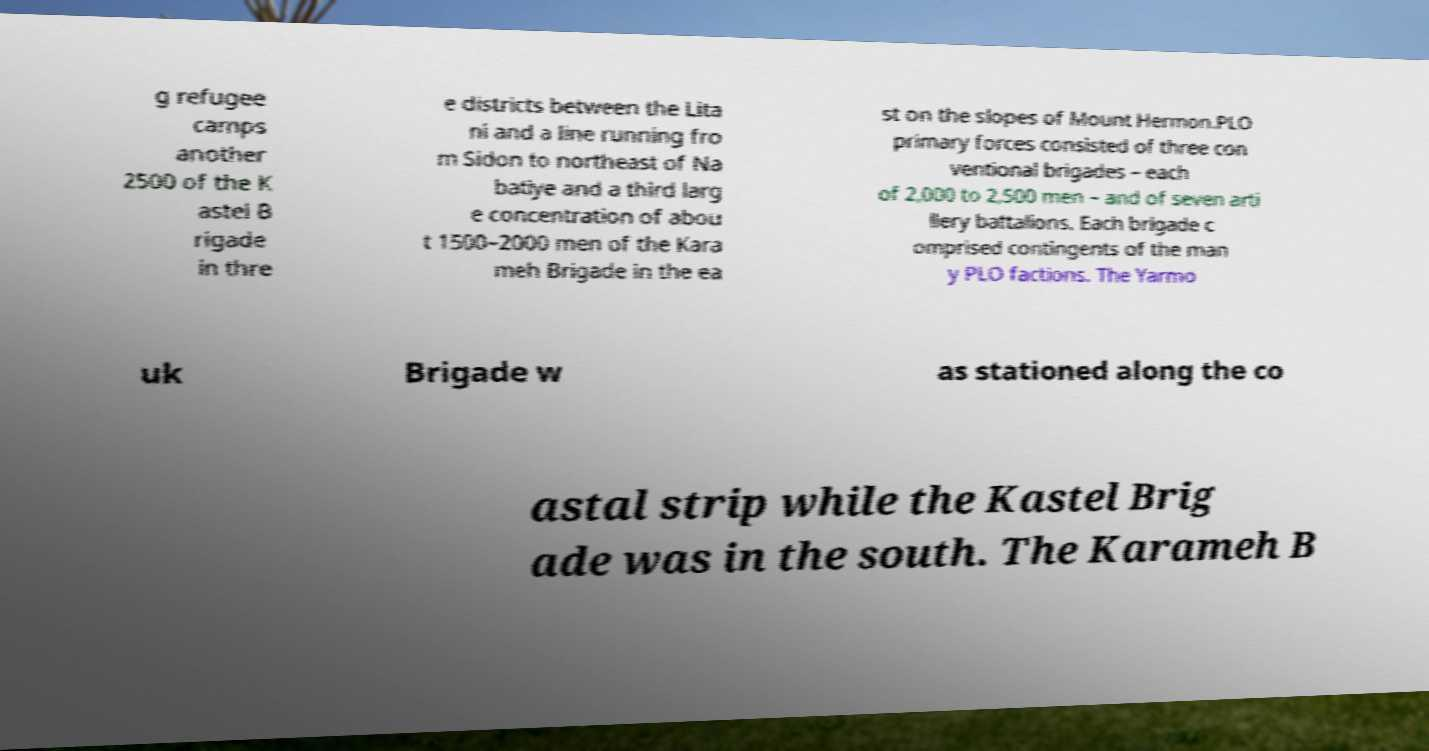For documentation purposes, I need the text within this image transcribed. Could you provide that? g refugee camps another 2500 of the K astel B rigade in thre e districts between the Lita ni and a line running fro m Sidon to northeast of Na batiye and a third larg e concentration of abou t 1500–2000 men of the Kara meh Brigade in the ea st on the slopes of Mount Hermon.PLO primary forces consisted of three con ventional brigades – each of 2,000 to 2,500 men – and of seven arti llery battalions. Each brigade c omprised contingents of the man y PLO factions. The Yarmo uk Brigade w as stationed along the co astal strip while the Kastel Brig ade was in the south. The Karameh B 